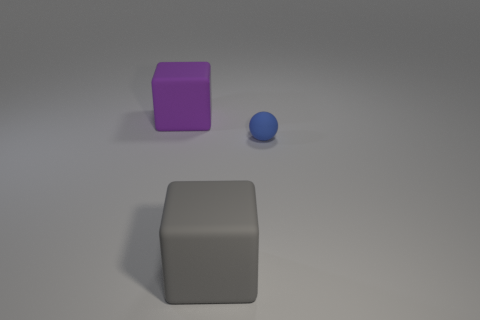Add 2 big gray cubes. How many objects exist? 5 Subtract 2 cubes. How many cubes are left? 0 Subtract all blocks. How many objects are left? 1 Subtract all green spheres. Subtract all blue cylinders. How many spheres are left? 1 Subtract all gray cylinders. How many green balls are left? 0 Subtract all big gray rubber things. Subtract all blue things. How many objects are left? 1 Add 2 small rubber things. How many small rubber things are left? 3 Add 3 large objects. How many large objects exist? 5 Subtract 1 purple cubes. How many objects are left? 2 